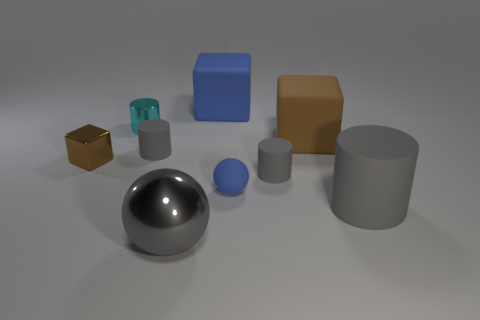Subtract all yellow cubes. How many gray cylinders are left? 3 Subtract 1 cylinders. How many cylinders are left? 3 Add 1 small cyan metal cylinders. How many objects exist? 10 Subtract all cubes. How many objects are left? 6 Add 6 brown things. How many brown things exist? 8 Subtract 0 cyan cubes. How many objects are left? 9 Subtract all green rubber spheres. Subtract all brown blocks. How many objects are left? 7 Add 1 tiny rubber cylinders. How many tiny rubber cylinders are left? 3 